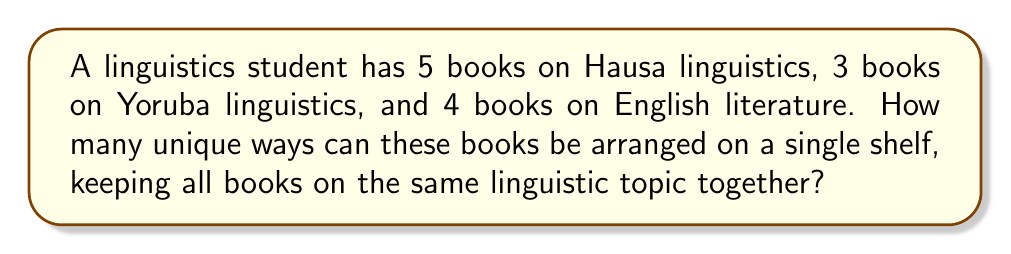Could you help me with this problem? Let's approach this step-by-step:

1) First, we need to consider the books on each topic as a single unit. So we have:
   - 1 unit of Hausa linguistics books
   - 1 unit of Yoruba linguistics books
   - 1 unit of English literature books

2) We need to find the number of ways to arrange these 3 units. This is a straightforward permutation:
   $$3! = 3 \times 2 \times 1 = 6$$

3) Now, within each unit, we need to consider the arrangements of individual books:
   - For Hausa linguistics: 5! ways
   - For Yoruba linguistics: 3! ways
   - For English literature: 4! ways

4) By the multiplication principle, the total number of arrangements is:
   $$3! \times 5! \times 3! \times 4!$$

5) Let's calculate this:
   $$6 \times 120 \times 6 \times 24 = 103,680$$

Therefore, there are 103,680 unique ways to arrange the books.
Answer: 103,680 